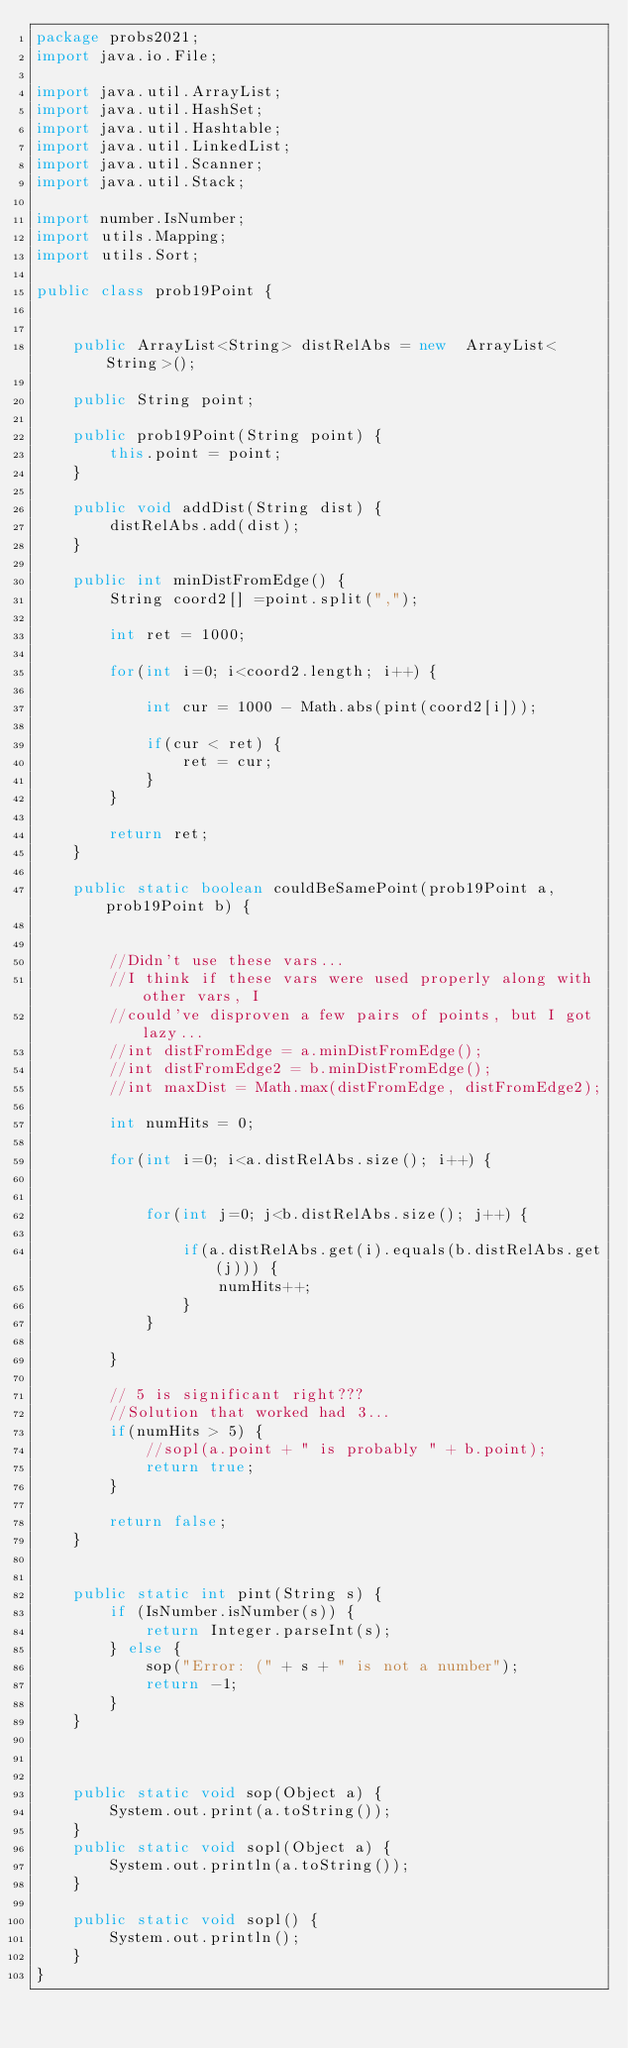Convert code to text. <code><loc_0><loc_0><loc_500><loc_500><_Java_>package probs2021;
import java.io.File;

import java.util.ArrayList;
import java.util.HashSet;
import java.util.Hashtable;
import java.util.LinkedList;
import java.util.Scanner;
import java.util.Stack;

import number.IsNumber;
import utils.Mapping;
import utils.Sort;

public class prob19Point {

	
	public ArrayList<String> distRelAbs = new  ArrayList<String>();
	
	public String point;
	
	public prob19Point(String point) {
		this.point = point;
	}
	
	public void addDist(String dist) {
		distRelAbs.add(dist);
	}
	
	public int minDistFromEdge() {
		String coord2[] =point.split(",");
		
		int ret = 1000;
		
		for(int i=0; i<coord2.length; i++) {
			
			int cur = 1000 - Math.abs(pint(coord2[i]));
			
			if(cur < ret) {
				ret = cur;
			}
		}
		
		return ret;
	}
	
	public static boolean couldBeSamePoint(prob19Point a, prob19Point b) {
		
		
		//Didn't use these vars...
		//I think if these vars were used properly along with other vars, I 
		//could've disproven a few pairs of points, but I got lazy...
		//int distFromEdge = a.minDistFromEdge();
		//int distFromEdge2 = b.minDistFromEdge();
		//int maxDist = Math.max(distFromEdge, distFromEdge2);
		
		int numHits = 0;
		
		for(int i=0; i<a.distRelAbs.size(); i++) {
			
				
			for(int j=0; j<b.distRelAbs.size(); j++) {
					
				if(a.distRelAbs.get(i).equals(b.distRelAbs.get(j))) {
					numHits++;
				}
			}
			
		}
		
		// 5 is significant right???
		//Solution that worked had 3...
		if(numHits > 5) {
			//sopl(a.point + " is probably " + b.point);
			return true;
		}
		
		return false;
	}
	

	public static int pint(String s) {
		if (IsNumber.isNumber(s)) {
			return Integer.parseInt(s);
		} else {
			sop("Error: (" + s + " is not a number");
			return -1;
		}
	}

	

	public static void sop(Object a) {
		System.out.print(a.toString());
	}
	public static void sopl(Object a) {
		System.out.println(a.toString());
	}

	public static void sopl() {
		System.out.println();
	}
}
</code> 